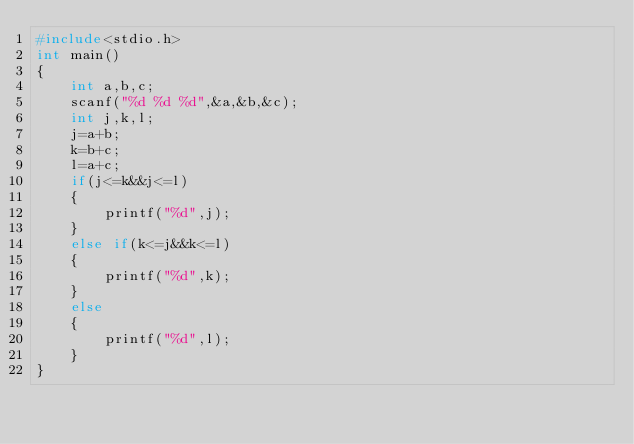<code> <loc_0><loc_0><loc_500><loc_500><_C_>#include<stdio.h>
int main()
{
    int a,b,c;
    scanf("%d %d %d",&a,&b,&c);
    int j,k,l;
    j=a+b;
    k=b+c;
    l=a+c;
    if(j<=k&&j<=l)
    {
        printf("%d",j);
    }
    else if(k<=j&&k<=l)
    {
        printf("%d",k);
    }
    else
    {
        printf("%d",l);
    }
}
</code> 